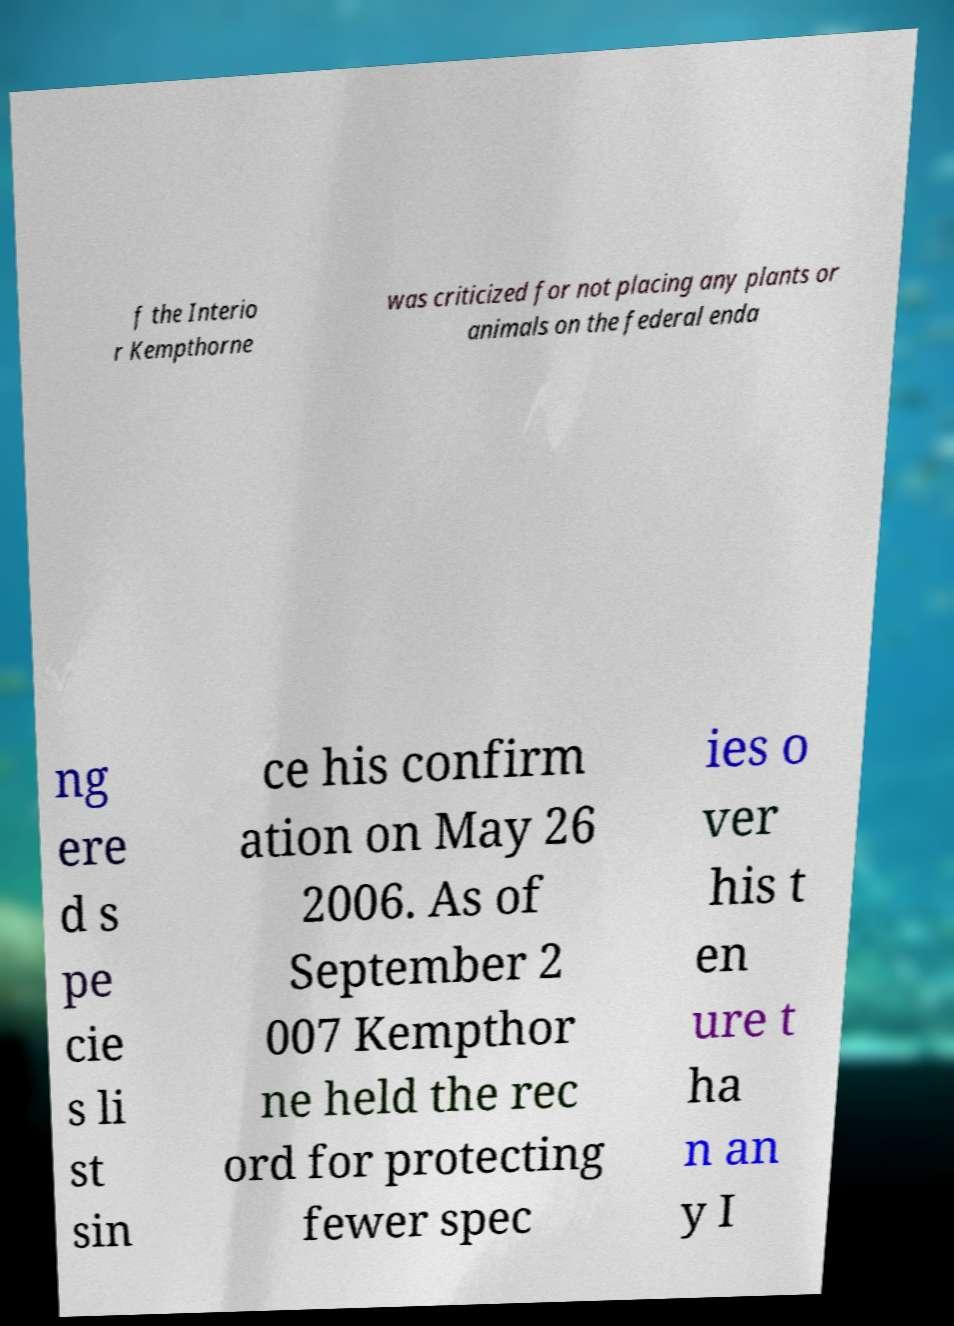Could you assist in decoding the text presented in this image and type it out clearly? f the Interio r Kempthorne was criticized for not placing any plants or animals on the federal enda ng ere d s pe cie s li st sin ce his confirm ation on May 26 2006. As of September 2 007 Kempthor ne held the rec ord for protecting fewer spec ies o ver his t en ure t ha n an y I 